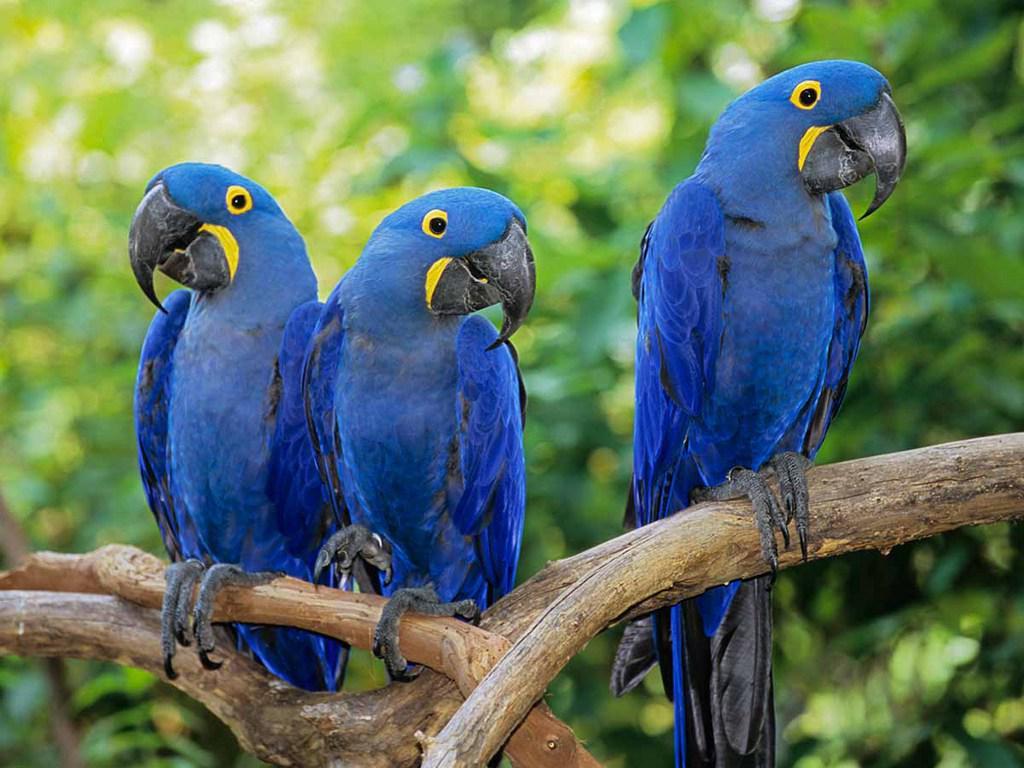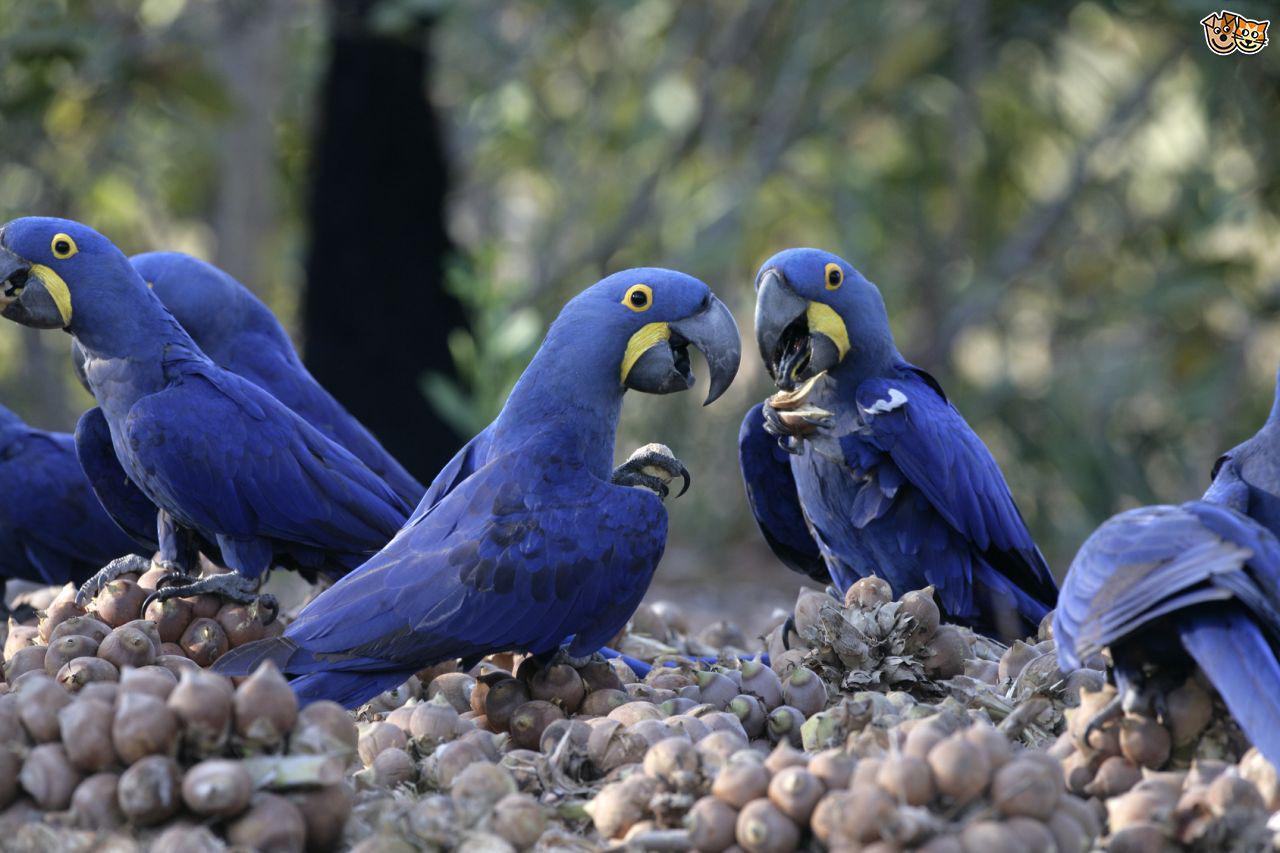The first image is the image on the left, the second image is the image on the right. Evaluate the accuracy of this statement regarding the images: "The right image contains at least two blue parrots.". Is it true? Answer yes or no. Yes. The first image is the image on the left, the second image is the image on the right. Considering the images on both sides, is "Each image contains at least two blue-feathered birds, and one image shows birds perched on leafless branches." valid? Answer yes or no. Yes. 